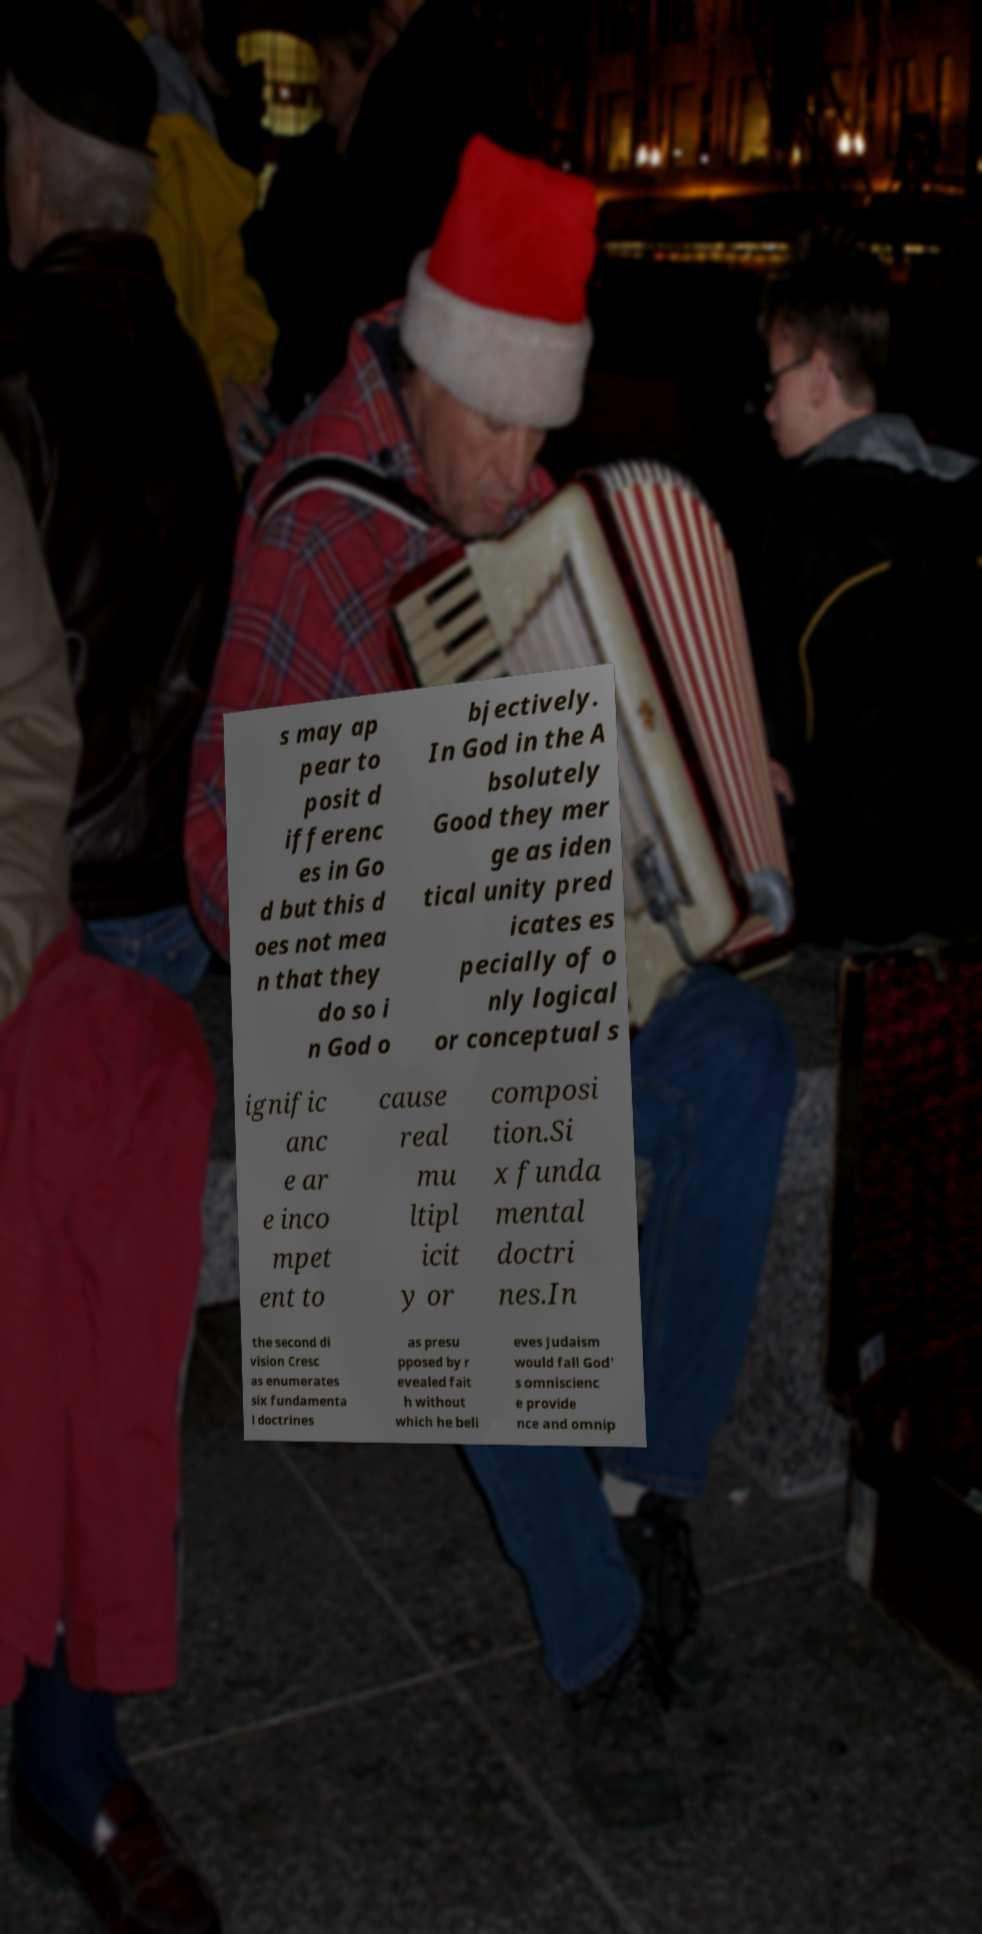Please identify and transcribe the text found in this image. s may ap pear to posit d ifferenc es in Go d but this d oes not mea n that they do so i n God o bjectively. In God in the A bsolutely Good they mer ge as iden tical unity pred icates es pecially of o nly logical or conceptual s ignific anc e ar e inco mpet ent to cause real mu ltipl icit y or composi tion.Si x funda mental doctri nes.In the second di vision Cresc as enumerates six fundamenta l doctrines as presu pposed by r evealed fait h without which he beli eves Judaism would fall God' s omniscienc e provide nce and omnip 